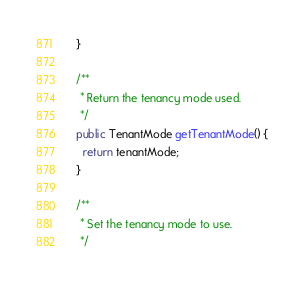Convert code to text. <code><loc_0><loc_0><loc_500><loc_500><_Java_>  }

  /**
   * Return the tenancy mode used.
   */
  public TenantMode getTenantMode() {
    return tenantMode;
  }

  /**
   * Set the tenancy mode to use.
   */</code> 